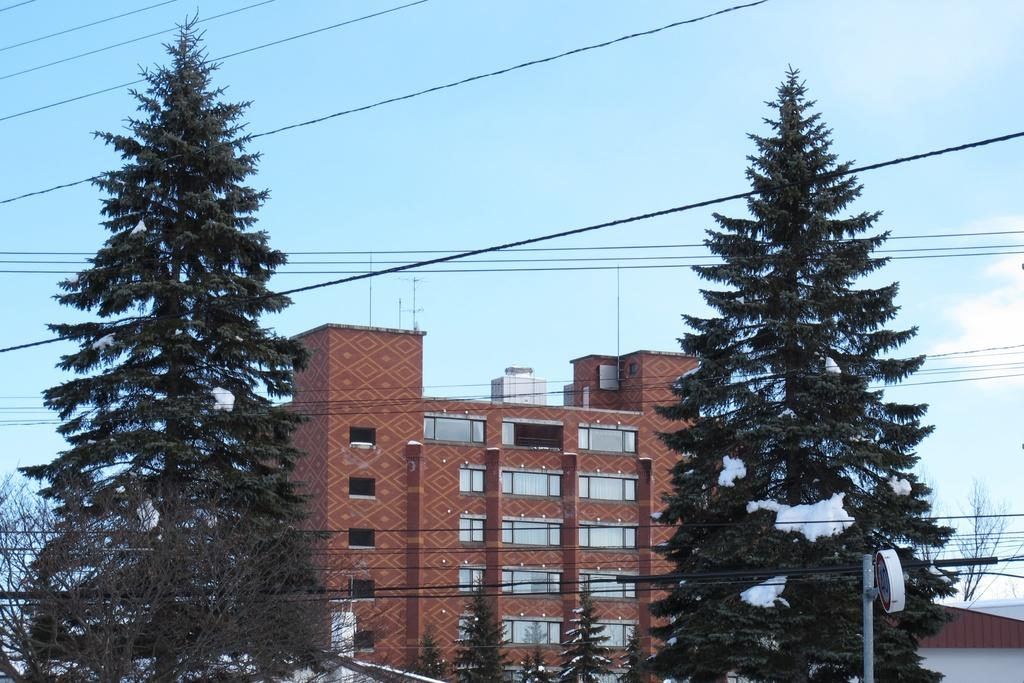What type of structure is visible in the image? There is a building with windows in the image. What natural elements can be seen in the image? There are trees and snow visible in the image. What man-made objects are present in the image? Wires, poles, and a signboard are present in the image. What is visible in the background of the image? The sky is visible in the background of the image. What time of day is it in the image, as indicated by the hour on the clock tower? There is no clock tower present in the image, so it is not possible to determine the time of day from the image. 